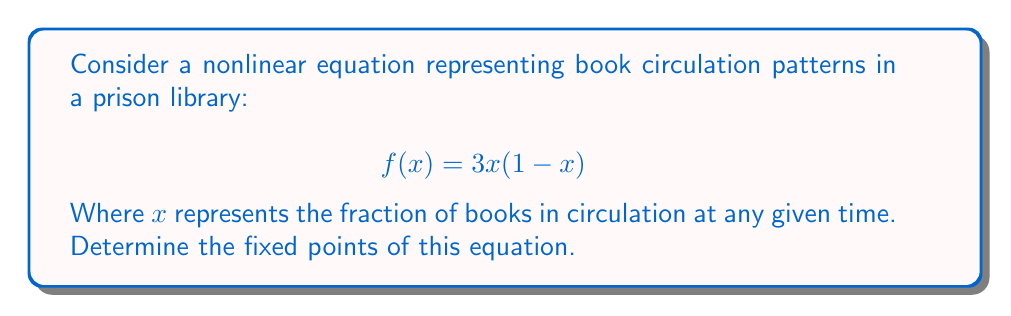Provide a solution to this math problem. To find the fixed points of the equation, we need to solve:

$$f(x) = x$$

Substituting the given function:

$$3x(1-x) = x$$

Expanding the left side:

$$3x - 3x^2 = x$$

Rearranging terms:

$$3x^2 - 2x = 0$$

Factoring out x:

$$x(3x - 2) = 0$$

The solutions to this equation are the x-values that make either factor equal to zero:

1) $x = 0$
2) $3x - 2 = 0$
   $3x = 2$
   $x = \frac{2}{3}$

Therefore, the fixed points of the equation are $x = 0$ and $x = \frac{2}{3}$.

Interpreting the results:
- $x = 0$ represents a situation where no books are in circulation.
- $x = \frac{2}{3}$ represents a stable equilibrium where approximately 67% of the books are in circulation.
Answer: $x = 0$ and $x = \frac{2}{3}$ 